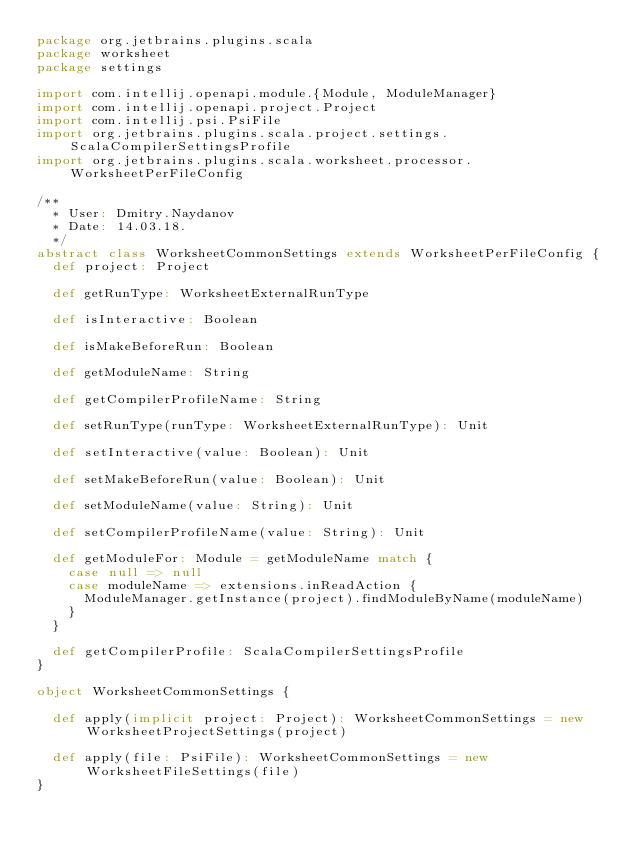<code> <loc_0><loc_0><loc_500><loc_500><_Scala_>package org.jetbrains.plugins.scala
package worksheet
package settings

import com.intellij.openapi.module.{Module, ModuleManager}
import com.intellij.openapi.project.Project
import com.intellij.psi.PsiFile
import org.jetbrains.plugins.scala.project.settings.ScalaCompilerSettingsProfile
import org.jetbrains.plugins.scala.worksheet.processor.WorksheetPerFileConfig

/**
  * User: Dmitry.Naydanov
  * Date: 14.03.18.
  */
abstract class WorksheetCommonSettings extends WorksheetPerFileConfig {
  def project: Project
  
  def getRunType: WorksheetExternalRunType
  
  def isInteractive: Boolean

  def isMakeBeforeRun: Boolean

  def getModuleName: String

  def getCompilerProfileName: String

  def setRunType(runType: WorksheetExternalRunType): Unit

  def setInteractive(value: Boolean): Unit

  def setMakeBeforeRun(value: Boolean): Unit

  def setModuleName(value: String): Unit

  def setCompilerProfileName(value: String): Unit

  def getModuleFor: Module = getModuleName match {
    case null => null
    case moduleName => extensions.inReadAction {
      ModuleManager.getInstance(project).findModuleByName(moduleName)
    }
  }

  def getCompilerProfile: ScalaCompilerSettingsProfile
}

object WorksheetCommonSettings {

  def apply(implicit project: Project): WorksheetCommonSettings = new WorksheetProjectSettings(project)

  def apply(file: PsiFile): WorksheetCommonSettings = new WorksheetFileSettings(file)
}</code> 